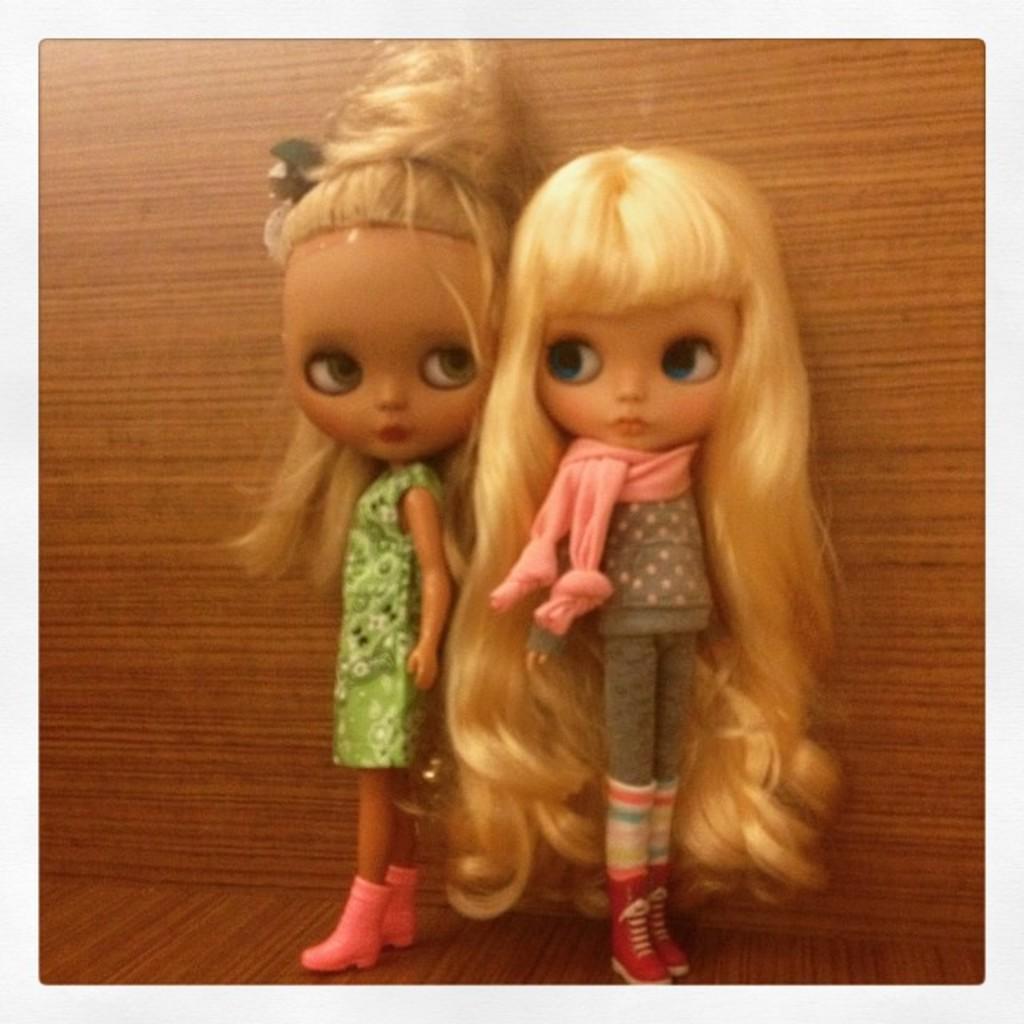How would you summarize this image in a sentence or two? This picture contains two dolls. The doll on the right side has a long hair. Behind the dolls, we see a brown color wooden wall. At the bottom of the picture, we see a wooden floor which is brown in color. 